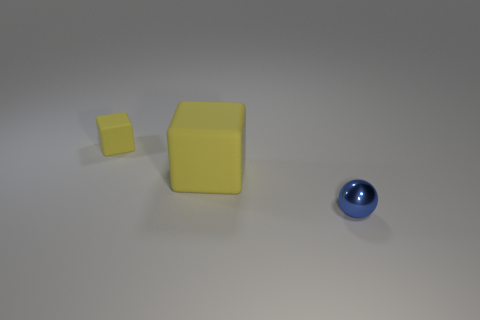Add 1 big rubber objects. How many objects exist? 4 Subtract all balls. How many objects are left? 2 Add 2 small blue metal objects. How many small blue metal objects are left? 3 Add 1 blue balls. How many blue balls exist? 2 Subtract 0 brown cubes. How many objects are left? 3 Subtract all small rubber objects. Subtract all rubber balls. How many objects are left? 2 